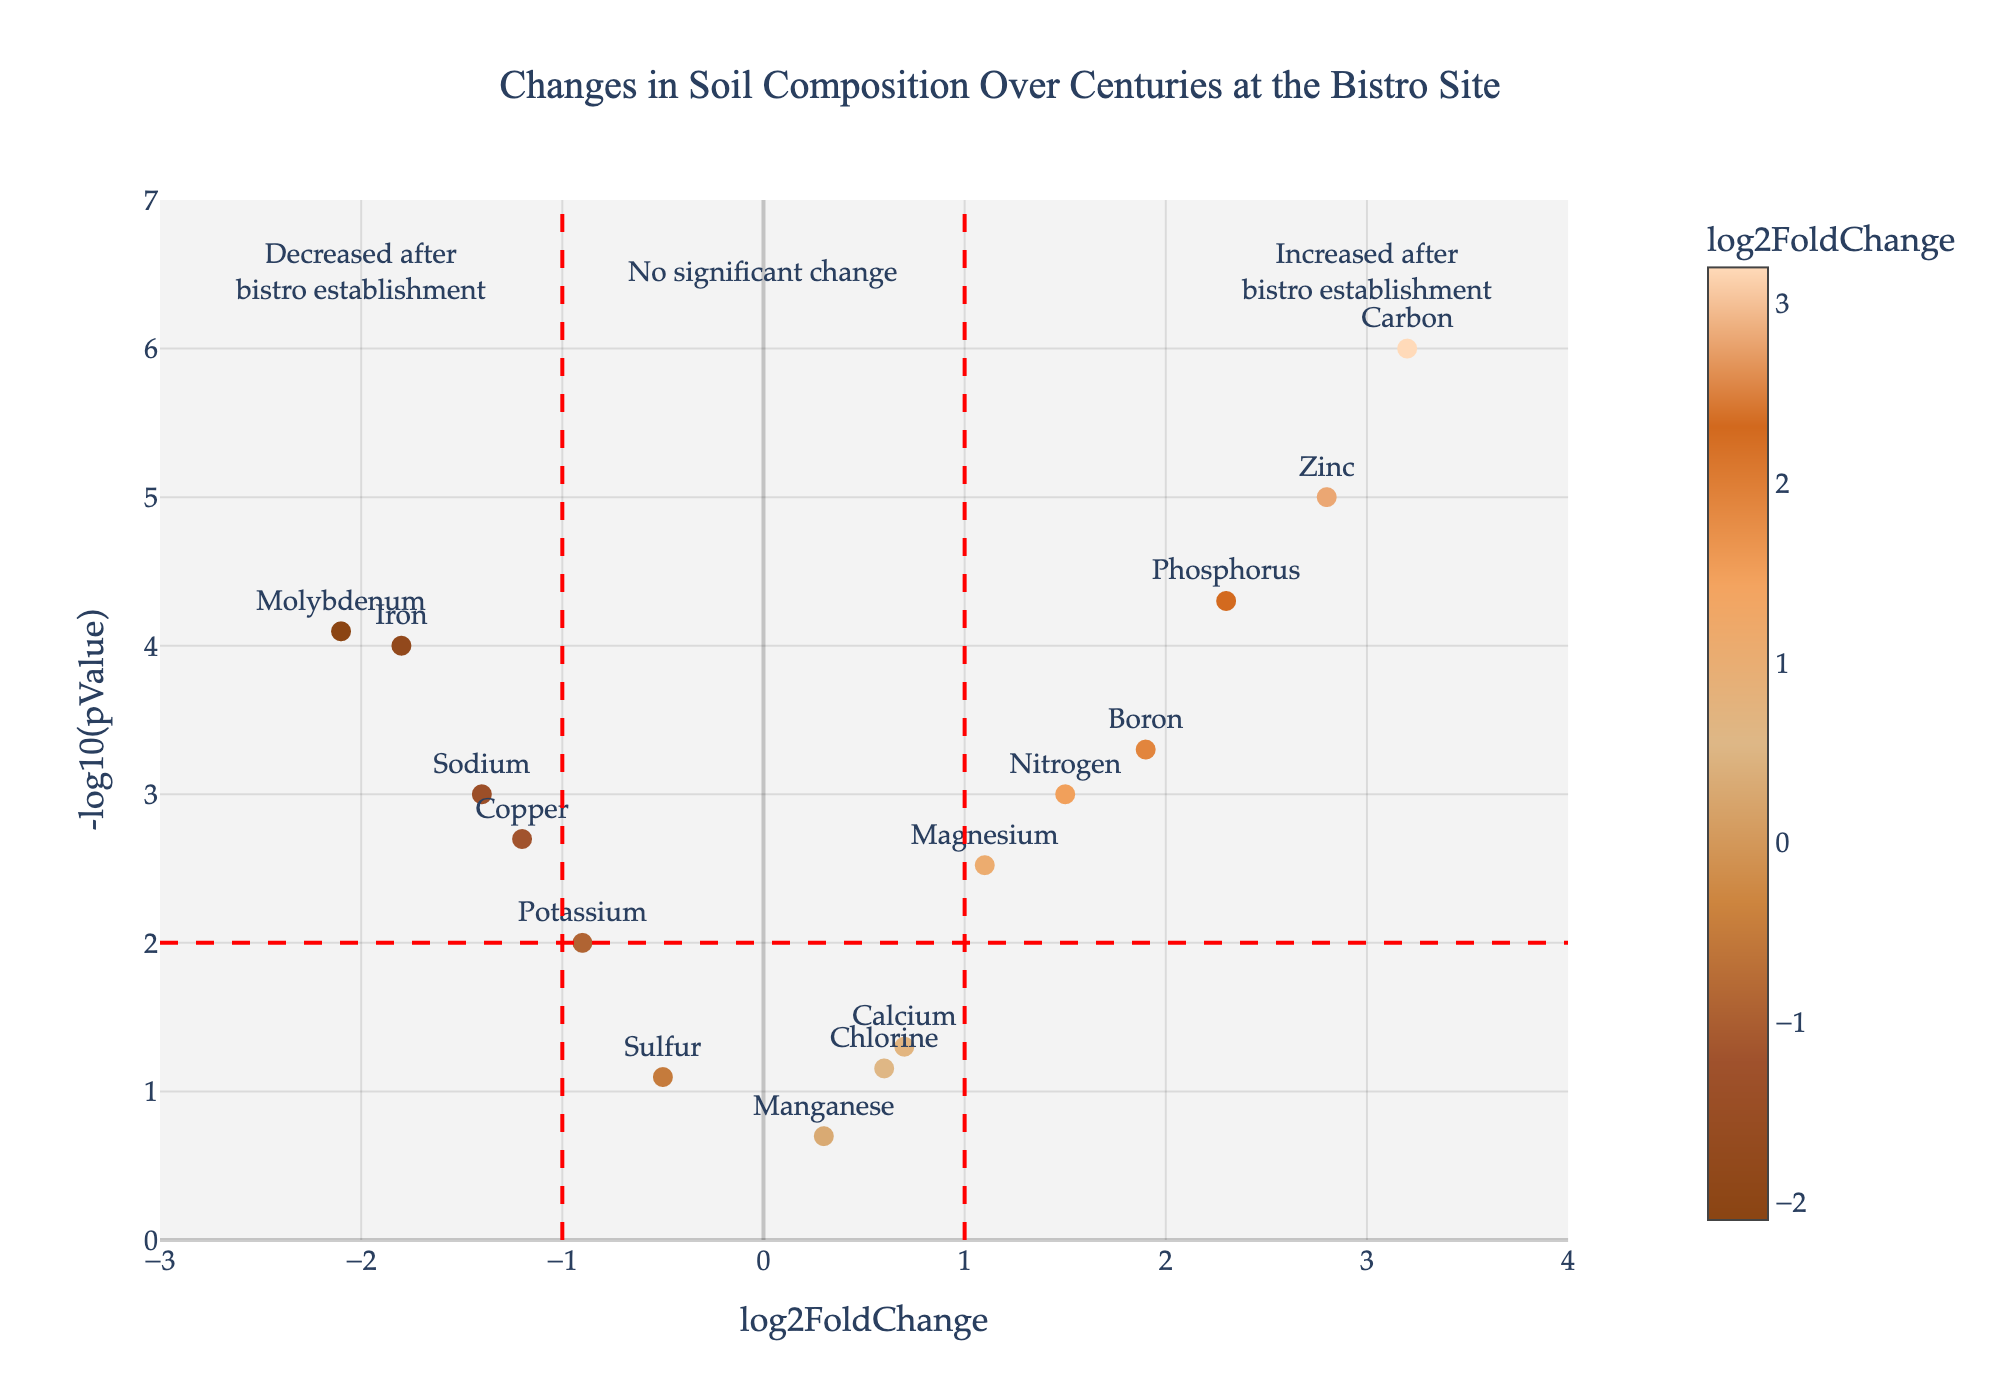What is the title of the plot? The title is usually found at the top of the plot and summarizes what the plot represents. In this case, it indicates the changes in soil composition over centuries at the bistro site.
Answer: Changes in Soil Composition Over Centuries at the Bistro Site Which element shows the most significant increase after the bistro establishment? Examine the plot to identify the element with the highest log2FoldChange value and a significant -log10(pValue). The element with the highest positive log2FoldChange is Carbon.
Answer: Carbon How many elements show a decrease after the bistro establishment? Elements showing a decrease have negative log2FoldChange values. Count the points on the left side of the y-axis and check their annotations.
Answer: 6 What does the dotted red vertical line at log2FoldChange = 1 signify? The vertical line at log2FoldChange = 1 helps visualize the threshold for significant increase in the element concentration after the bistro establishment.
Answer: Significant increase threshold What range of log2FoldChange is covered by the x-axis? Examine the x-axis values from the leftmost to the rightmost points to determine the range of log2FoldChange values displayed.
Answer: -3 to 4 Which element shows the highest statistical significance? Although various elements may have low p-values, the highest statistical significance is associated with the lowest p-value, corresponding to the highest -log10(pValue). In this case, Zinc has the highest -log10(pValue).
Answer: Zinc Is there any element that has not significantly changed after the bistro establishment? Determine if there are elements where the -log10(pValue) is less than 2, indicating no statistical significance. Manganese and Chlorine have relatively low -log10(pValue) values and are close to the center of the x-axis, indicating no significant change.
Answer: Yes, Manganese Compare the changes in Magnesium and Calcium. Which one increased more significantly? Compare the log2FoldChange and -log10(pValue) for Magnesium and Calcium. Magnesium has a higher log2FoldChange and -log10(pValue), indicating a more significant increase.
Answer: Magnesium What kind of trend do we observe in Phosphorus levels after the bistro establishment? By observing the position of Phosphorus on the plot, it has a positive log2FoldChange and a high -log10(pValue), indicating a significant increase.
Answer: Significant increase What does a negative log2FoldChange indicate in this plot? A negative log2FoldChange indicates that the concentration of the element decreased after the establishment of the bistro compared to the pre-establishment period.
Answer: Decrease in concentration 